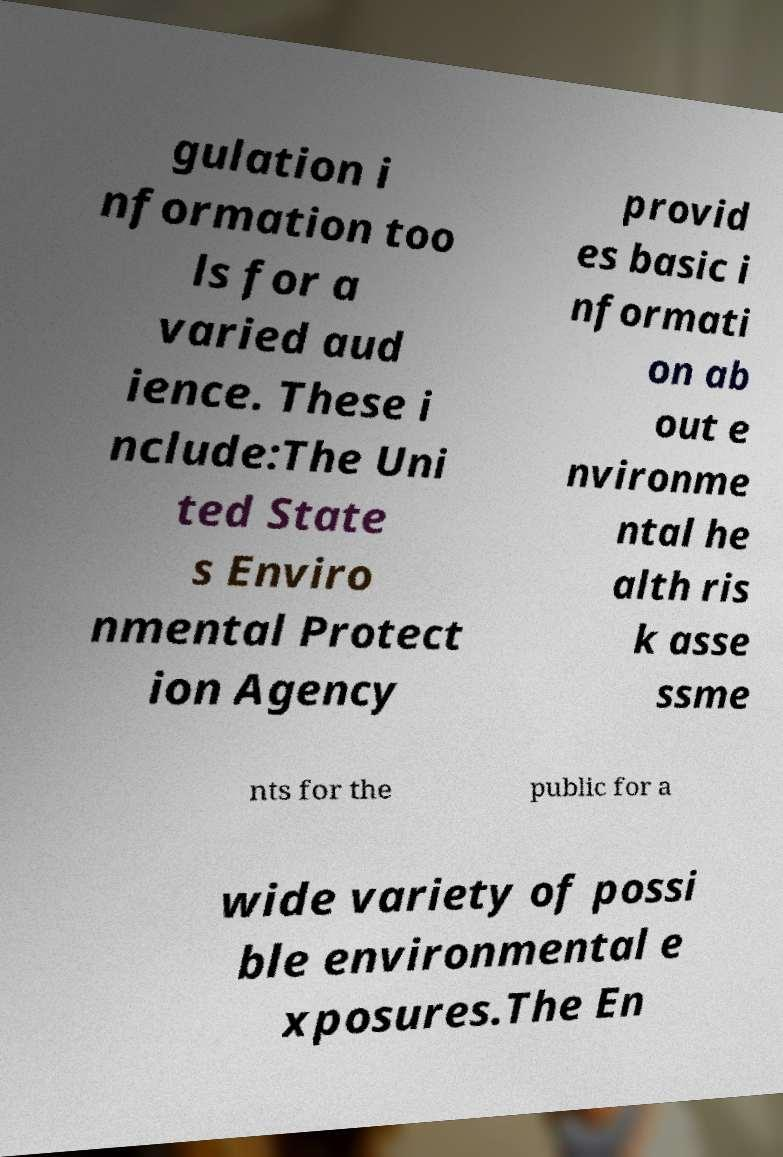Please identify and transcribe the text found in this image. gulation i nformation too ls for a varied aud ience. These i nclude:The Uni ted State s Enviro nmental Protect ion Agency provid es basic i nformati on ab out e nvironme ntal he alth ris k asse ssme nts for the public for a wide variety of possi ble environmental e xposures.The En 